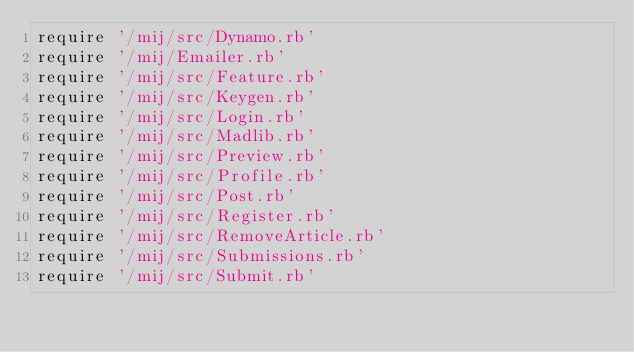Convert code to text. <code><loc_0><loc_0><loc_500><loc_500><_Ruby_>require '/mij/src/Dynamo.rb'
require '/mij/Emailer.rb'
require '/mij/src/Feature.rb'
require '/mij/src/Keygen.rb'
require '/mij/src/Login.rb'
require '/mij/src/Madlib.rb'
require '/mij/src/Preview.rb'
require '/mij/src/Profile.rb'
require '/mij/src/Post.rb'
require '/mij/src/Register.rb'
require '/mij/src/RemoveArticle.rb'
require '/mij/src/Submissions.rb'
require '/mij/src/Submit.rb'</code> 